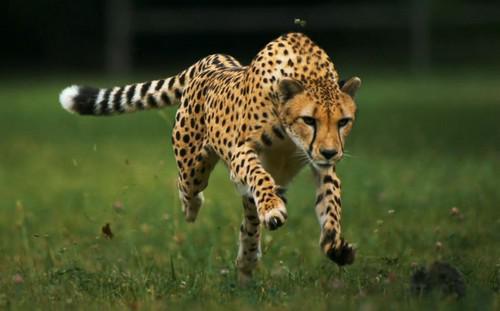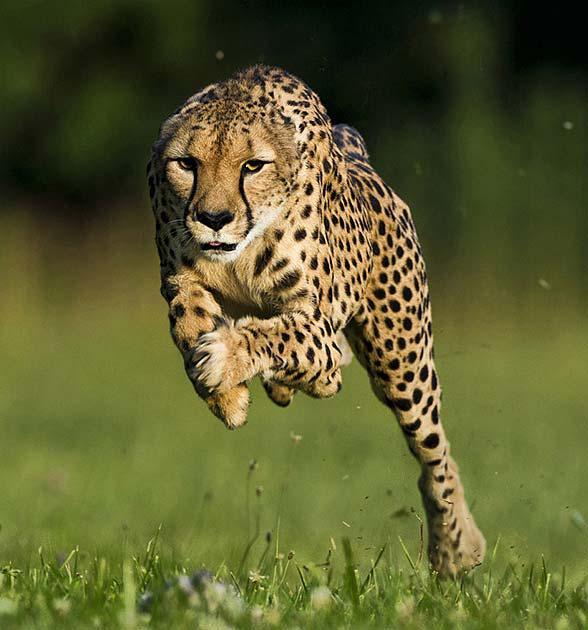The first image is the image on the left, the second image is the image on the right. For the images displayed, is the sentence "A cheetah has its mouth partially open." factually correct? Answer yes or no. No. 